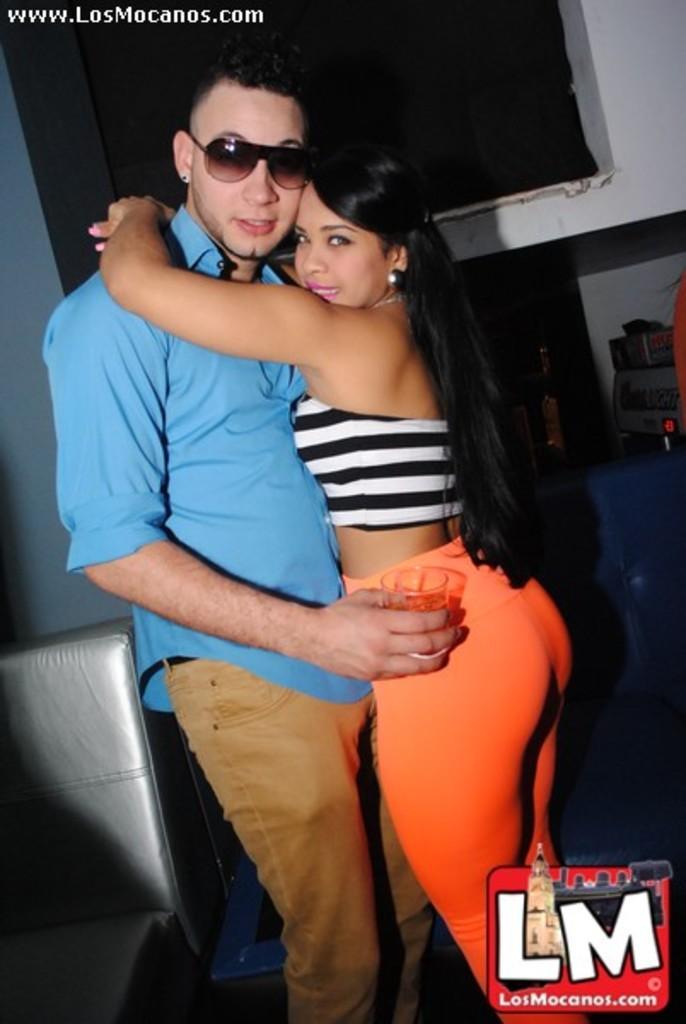In one or two sentences, can you explain what this image depicts? In this image we can see a man and a woman are hugging to each other. The man is wearing blue color shirt with brown jeans and holding a glass in his hand. The woman is wearing a white and black top with orange pant. At the left bottom of the image silver color sofa is there. Background of the image white color wall and things are present. At the right bottom of the image logo is there. 